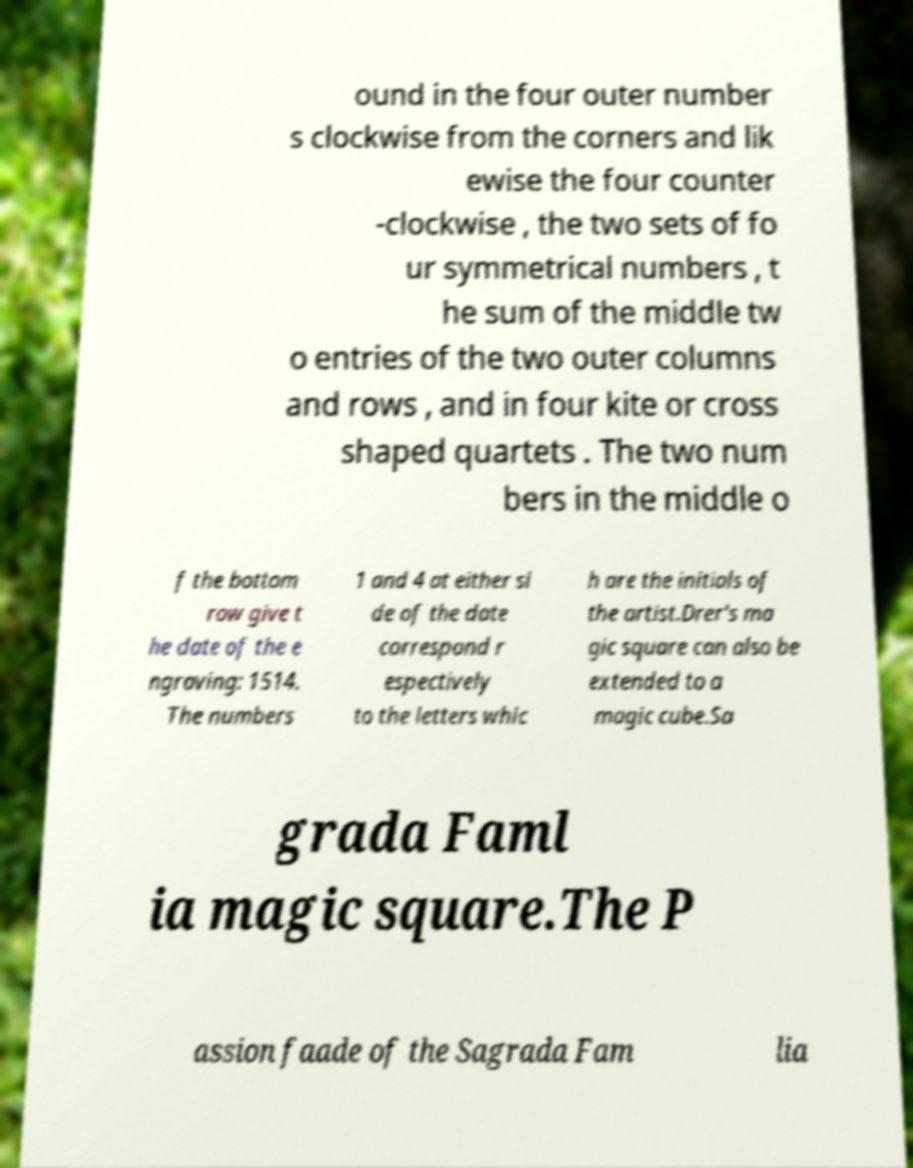I need the written content from this picture converted into text. Can you do that? ound in the four outer number s clockwise from the corners and lik ewise the four counter -clockwise , the two sets of fo ur symmetrical numbers , t he sum of the middle tw o entries of the two outer columns and rows , and in four kite or cross shaped quartets . The two num bers in the middle o f the bottom row give t he date of the e ngraving: 1514. The numbers 1 and 4 at either si de of the date correspond r espectively to the letters whic h are the initials of the artist.Drer's ma gic square can also be extended to a magic cube.Sa grada Faml ia magic square.The P assion faade of the Sagrada Fam lia 